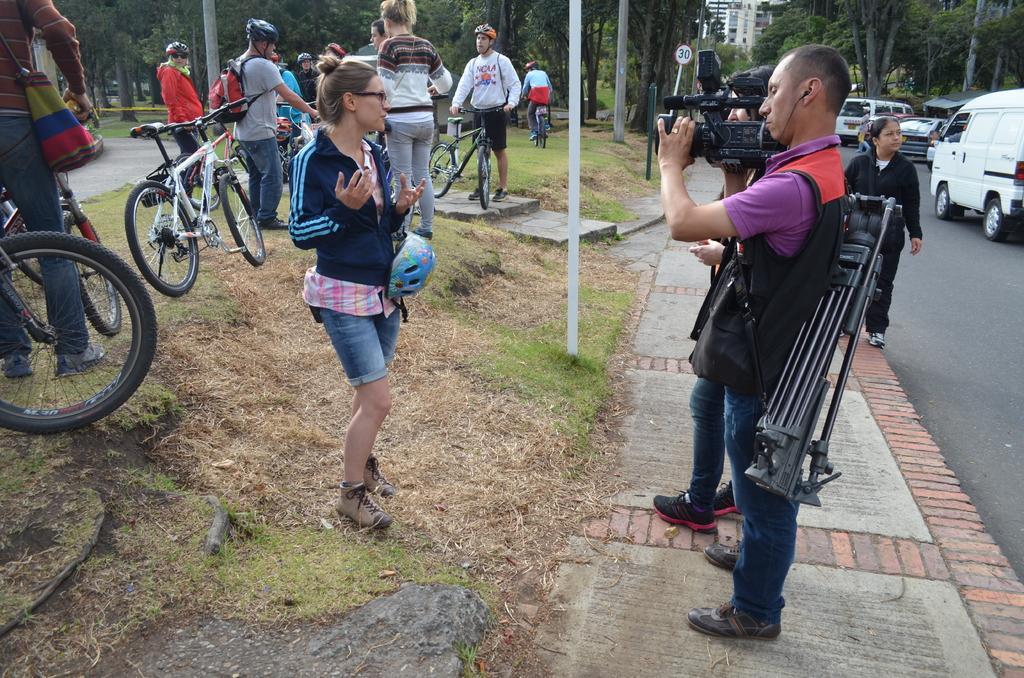Could you give a brief overview of what you see in this image? This image is taken outdoors. At the bottom of the image there is a ground with grass on it. There is a road and there is a sidewalk. In the background there is a building and there are many trees and plants on the ground. On the right side of the image a few vehicles are parked on the road and a van is moving on the road. On the left side of the image many people are standing on the ground and a few bicycles are parked on the ground. A woman is standing on the ground and two men are standing on the sidewalk and clicking pictures of a woman with a camera and a woman is walking on the sidewalk. 